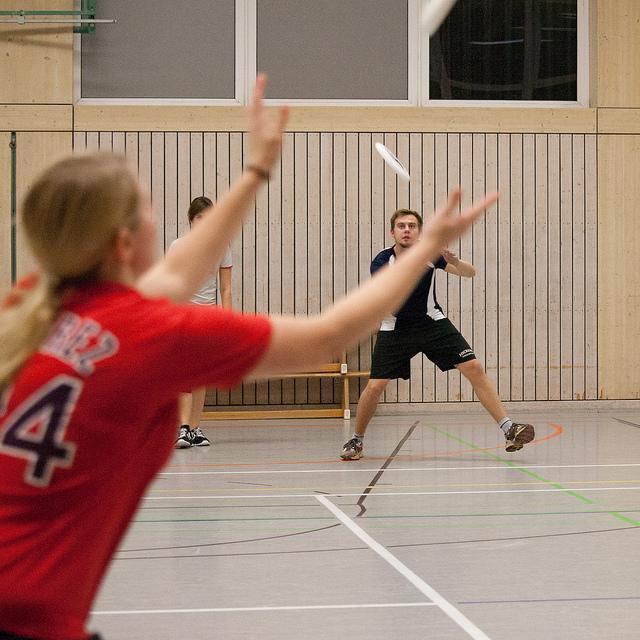How many windows are shown?
Give a very brief answer. 3. How many benches can you see?
Give a very brief answer. 1. How many people are in the photo?
Give a very brief answer. 3. How many pink umbrellas are in this image?
Give a very brief answer. 0. 